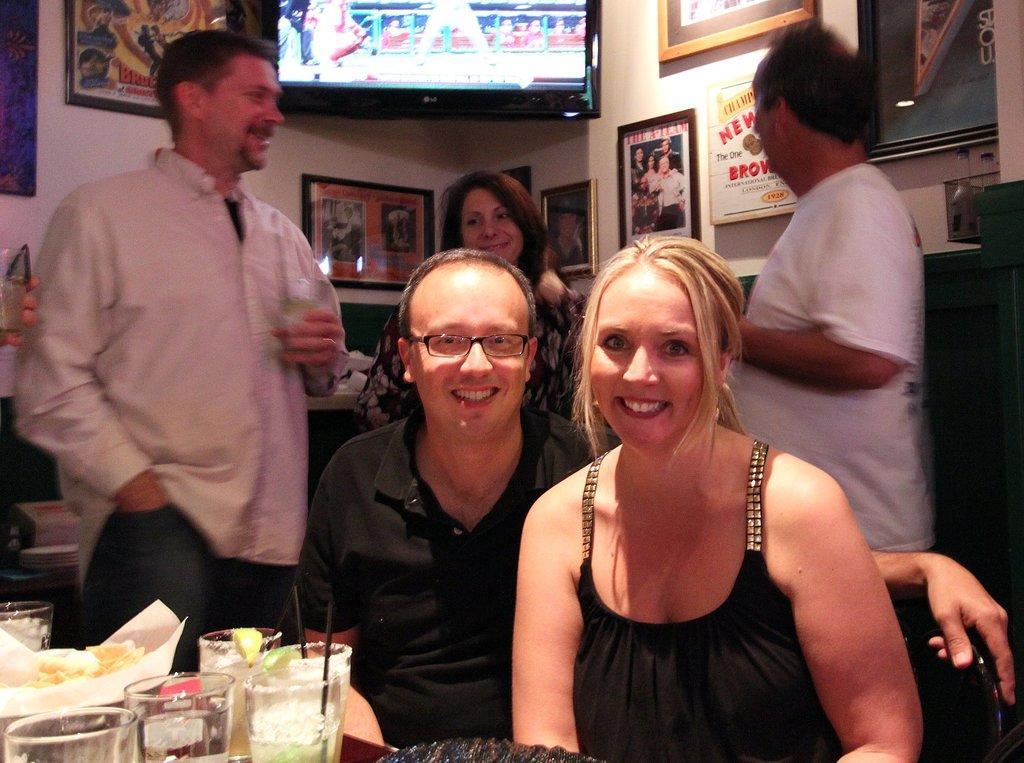How would you summarize this image in a sentence or two? Here we can see a man and a woman are sitting on the chairs and on the left there are glasses with liquid in it and a food item on a tissue paper are on a table. In the background there are three persons standing,frames and screen on the wall and other objects. 